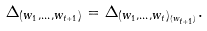<formula> <loc_0><loc_0><loc_500><loc_500>\Delta _ { ( w _ { 1 } , \dots , w _ { t + 1 } ) } = \Delta _ { ( w _ { 1 } , \dots , w _ { t } ) _ { ( w _ { t + 1 } ) } } .</formula> 